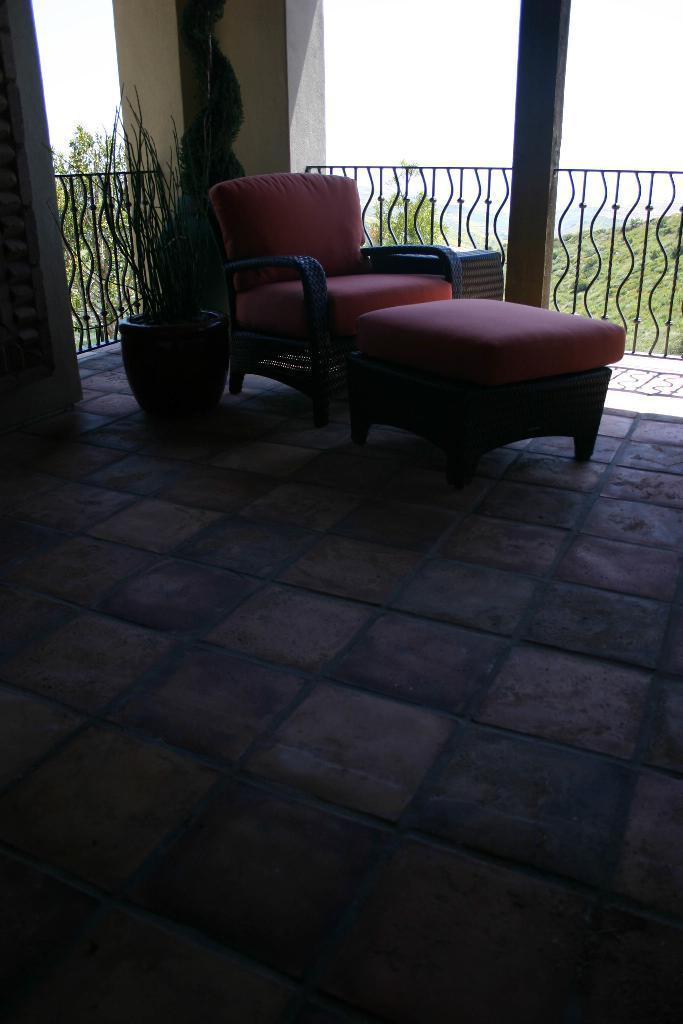Describe this image in one or two sentences. The image is inside the room. In the image there is a couch on right side in background we can see a metal fence,trees and sky is on top. 